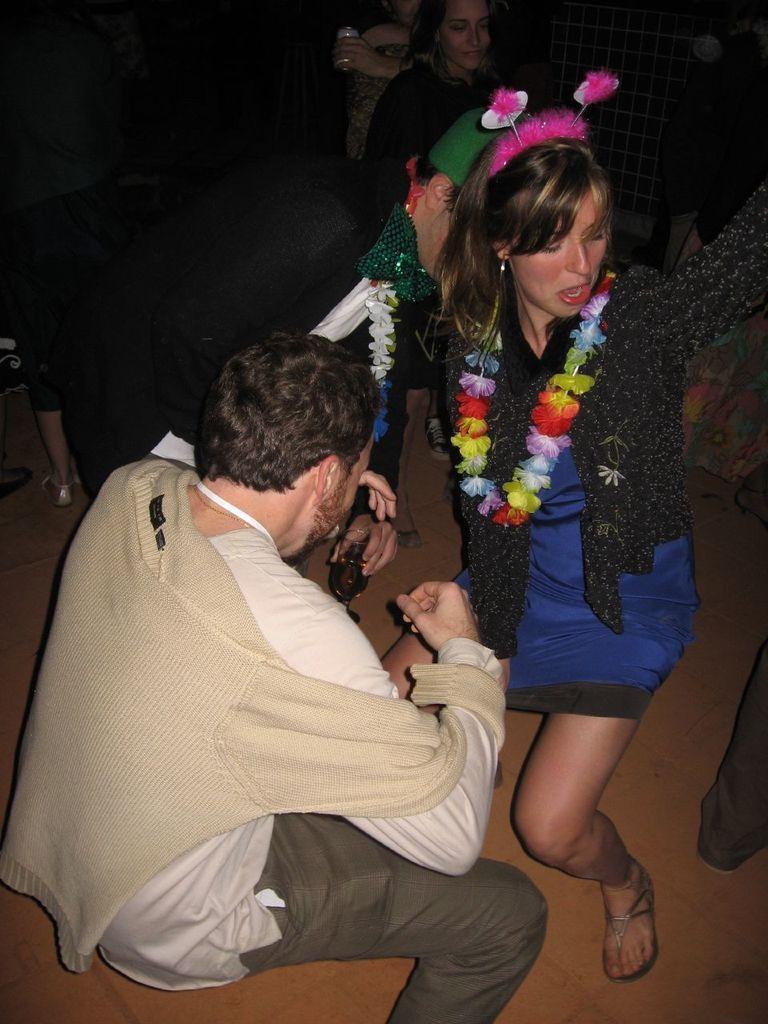Can you describe this image briefly? In this picture there is a man at the bottom left and he is holding a glass. Towards the right, there is a woman wearing a blue and black dress. Behind the women, there are people. 